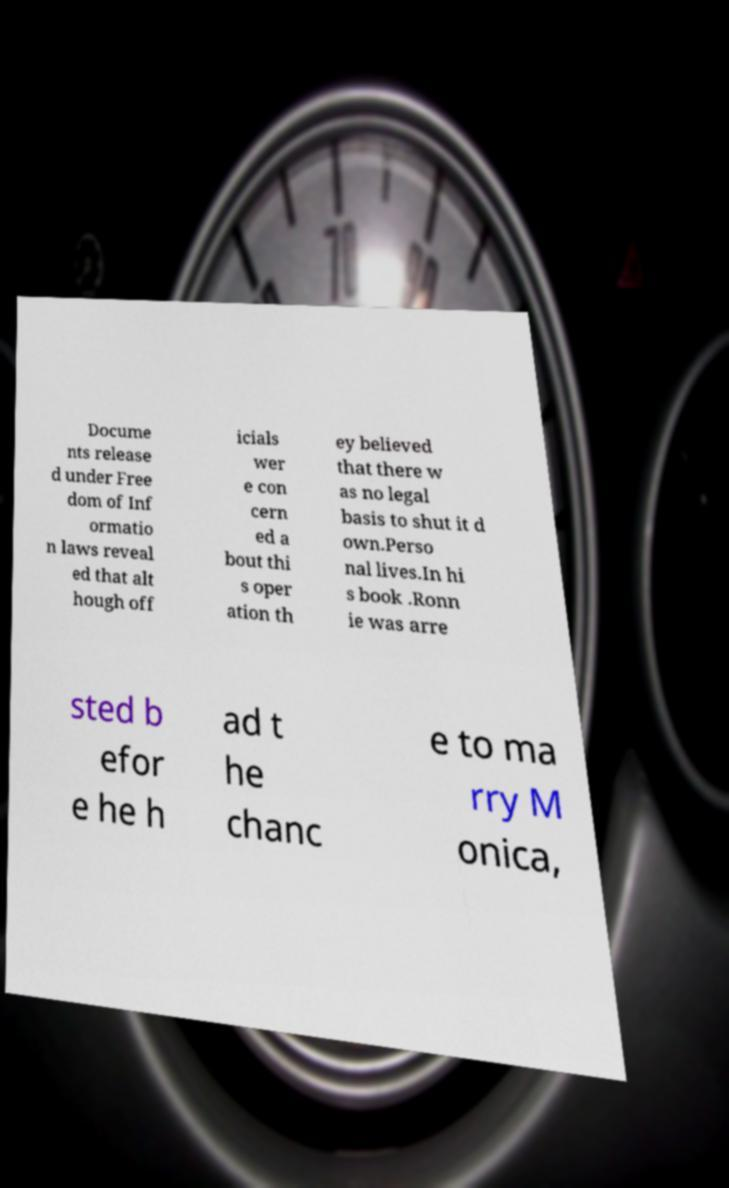Could you assist in decoding the text presented in this image and type it out clearly? Docume nts release d under Free dom of Inf ormatio n laws reveal ed that alt hough off icials wer e con cern ed a bout thi s oper ation th ey believed that there w as no legal basis to shut it d own.Perso nal lives.In hi s book .Ronn ie was arre sted b efor e he h ad t he chanc e to ma rry M onica, 